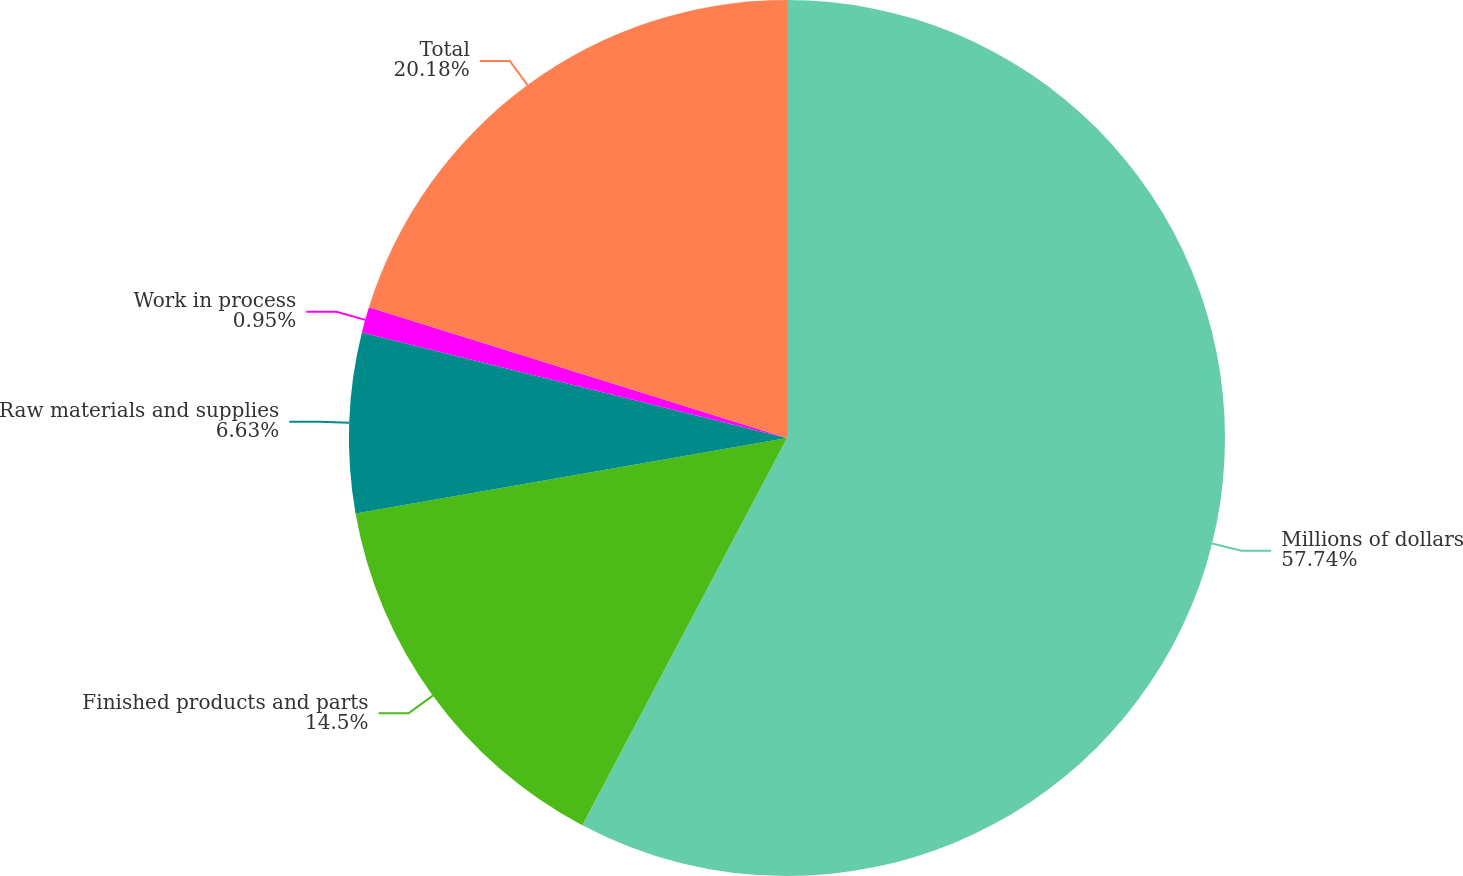Convert chart. <chart><loc_0><loc_0><loc_500><loc_500><pie_chart><fcel>Millions of dollars<fcel>Finished products and parts<fcel>Raw materials and supplies<fcel>Work in process<fcel>Total<nl><fcel>57.74%<fcel>14.5%<fcel>6.63%<fcel>0.95%<fcel>20.18%<nl></chart> 